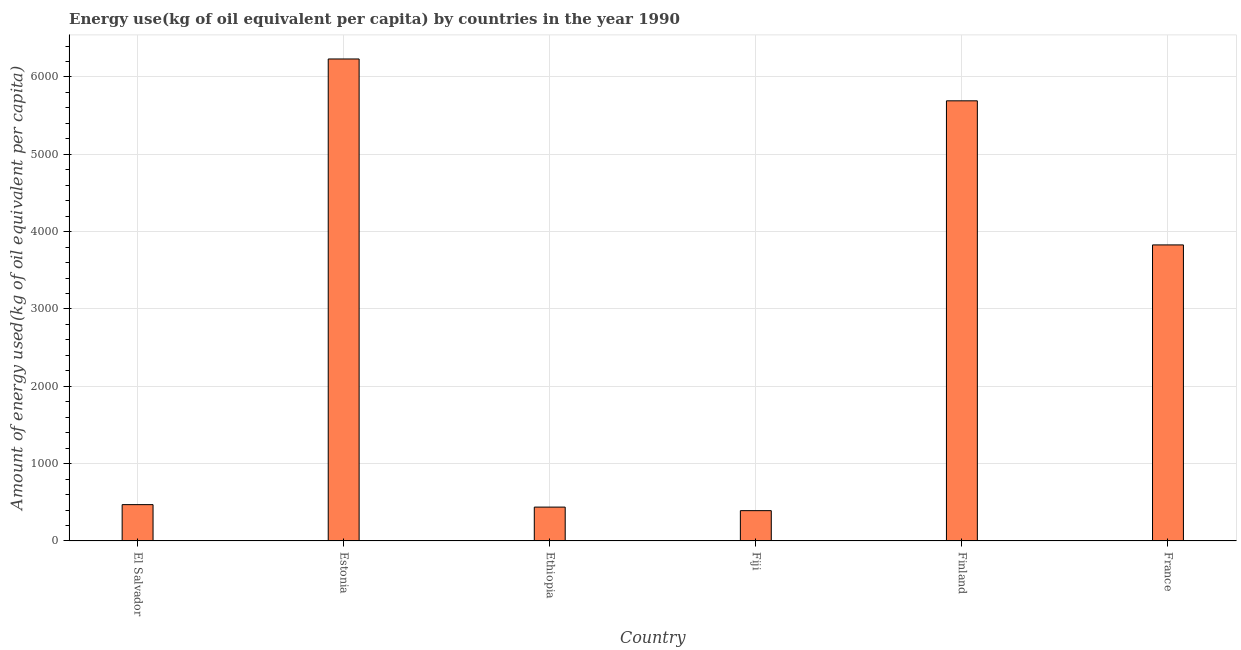What is the title of the graph?
Your answer should be compact. Energy use(kg of oil equivalent per capita) by countries in the year 1990. What is the label or title of the X-axis?
Your answer should be compact. Country. What is the label or title of the Y-axis?
Ensure brevity in your answer.  Amount of energy used(kg of oil equivalent per capita). What is the amount of energy used in France?
Give a very brief answer. 3828.33. Across all countries, what is the maximum amount of energy used?
Make the answer very short. 6232.73. Across all countries, what is the minimum amount of energy used?
Keep it short and to the point. 392.25. In which country was the amount of energy used maximum?
Your response must be concise. Estonia. In which country was the amount of energy used minimum?
Your answer should be very brief. Fiji. What is the sum of the amount of energy used?
Ensure brevity in your answer.  1.71e+04. What is the difference between the amount of energy used in El Salvador and Ethiopia?
Keep it short and to the point. 32.09. What is the average amount of energy used per country?
Your answer should be compact. 2842.15. What is the median amount of energy used?
Offer a terse response. 2149.19. What is the ratio of the amount of energy used in Ethiopia to that in Fiji?
Offer a very short reply. 1.12. Is the amount of energy used in Fiji less than that in France?
Keep it short and to the point. Yes. What is the difference between the highest and the second highest amount of energy used?
Provide a short and direct response. 541.16. What is the difference between the highest and the lowest amount of energy used?
Offer a very short reply. 5840.48. Are all the bars in the graph horizontal?
Keep it short and to the point. No. How many countries are there in the graph?
Provide a succinct answer. 6. What is the difference between two consecutive major ticks on the Y-axis?
Your answer should be compact. 1000. Are the values on the major ticks of Y-axis written in scientific E-notation?
Give a very brief answer. No. What is the Amount of energy used(kg of oil equivalent per capita) in El Salvador?
Provide a succinct answer. 470.04. What is the Amount of energy used(kg of oil equivalent per capita) in Estonia?
Your answer should be compact. 6232.73. What is the Amount of energy used(kg of oil equivalent per capita) of Ethiopia?
Make the answer very short. 437.95. What is the Amount of energy used(kg of oil equivalent per capita) in Fiji?
Provide a succinct answer. 392.25. What is the Amount of energy used(kg of oil equivalent per capita) of Finland?
Your answer should be very brief. 5691.57. What is the Amount of energy used(kg of oil equivalent per capita) of France?
Offer a terse response. 3828.33. What is the difference between the Amount of energy used(kg of oil equivalent per capita) in El Salvador and Estonia?
Make the answer very short. -5762.69. What is the difference between the Amount of energy used(kg of oil equivalent per capita) in El Salvador and Ethiopia?
Provide a short and direct response. 32.09. What is the difference between the Amount of energy used(kg of oil equivalent per capita) in El Salvador and Fiji?
Make the answer very short. 77.79. What is the difference between the Amount of energy used(kg of oil equivalent per capita) in El Salvador and Finland?
Provide a short and direct response. -5221.53. What is the difference between the Amount of energy used(kg of oil equivalent per capita) in El Salvador and France?
Your answer should be compact. -3358.28. What is the difference between the Amount of energy used(kg of oil equivalent per capita) in Estonia and Ethiopia?
Give a very brief answer. 5794.78. What is the difference between the Amount of energy used(kg of oil equivalent per capita) in Estonia and Fiji?
Ensure brevity in your answer.  5840.48. What is the difference between the Amount of energy used(kg of oil equivalent per capita) in Estonia and Finland?
Provide a succinct answer. 541.16. What is the difference between the Amount of energy used(kg of oil equivalent per capita) in Estonia and France?
Your answer should be very brief. 2404.4. What is the difference between the Amount of energy used(kg of oil equivalent per capita) in Ethiopia and Fiji?
Offer a very short reply. 45.7. What is the difference between the Amount of energy used(kg of oil equivalent per capita) in Ethiopia and Finland?
Give a very brief answer. -5253.62. What is the difference between the Amount of energy used(kg of oil equivalent per capita) in Ethiopia and France?
Offer a very short reply. -3390.37. What is the difference between the Amount of energy used(kg of oil equivalent per capita) in Fiji and Finland?
Your answer should be compact. -5299.32. What is the difference between the Amount of energy used(kg of oil equivalent per capita) in Fiji and France?
Ensure brevity in your answer.  -3436.07. What is the difference between the Amount of energy used(kg of oil equivalent per capita) in Finland and France?
Offer a very short reply. 1863.24. What is the ratio of the Amount of energy used(kg of oil equivalent per capita) in El Salvador to that in Estonia?
Your response must be concise. 0.07. What is the ratio of the Amount of energy used(kg of oil equivalent per capita) in El Salvador to that in Ethiopia?
Give a very brief answer. 1.07. What is the ratio of the Amount of energy used(kg of oil equivalent per capita) in El Salvador to that in Fiji?
Your answer should be very brief. 1.2. What is the ratio of the Amount of energy used(kg of oil equivalent per capita) in El Salvador to that in Finland?
Provide a succinct answer. 0.08. What is the ratio of the Amount of energy used(kg of oil equivalent per capita) in El Salvador to that in France?
Your answer should be very brief. 0.12. What is the ratio of the Amount of energy used(kg of oil equivalent per capita) in Estonia to that in Ethiopia?
Give a very brief answer. 14.23. What is the ratio of the Amount of energy used(kg of oil equivalent per capita) in Estonia to that in Fiji?
Offer a terse response. 15.89. What is the ratio of the Amount of energy used(kg of oil equivalent per capita) in Estonia to that in Finland?
Provide a succinct answer. 1.09. What is the ratio of the Amount of energy used(kg of oil equivalent per capita) in Estonia to that in France?
Make the answer very short. 1.63. What is the ratio of the Amount of energy used(kg of oil equivalent per capita) in Ethiopia to that in Fiji?
Provide a short and direct response. 1.12. What is the ratio of the Amount of energy used(kg of oil equivalent per capita) in Ethiopia to that in Finland?
Keep it short and to the point. 0.08. What is the ratio of the Amount of energy used(kg of oil equivalent per capita) in Ethiopia to that in France?
Provide a succinct answer. 0.11. What is the ratio of the Amount of energy used(kg of oil equivalent per capita) in Fiji to that in Finland?
Offer a very short reply. 0.07. What is the ratio of the Amount of energy used(kg of oil equivalent per capita) in Fiji to that in France?
Offer a very short reply. 0.1. What is the ratio of the Amount of energy used(kg of oil equivalent per capita) in Finland to that in France?
Your answer should be compact. 1.49. 